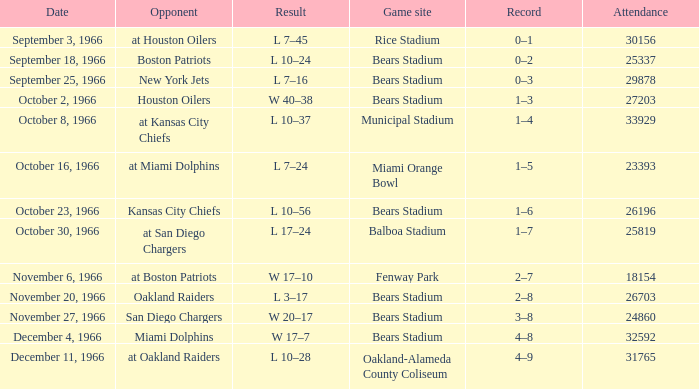When was the game played against the miami dolphins? December 4, 1966. 